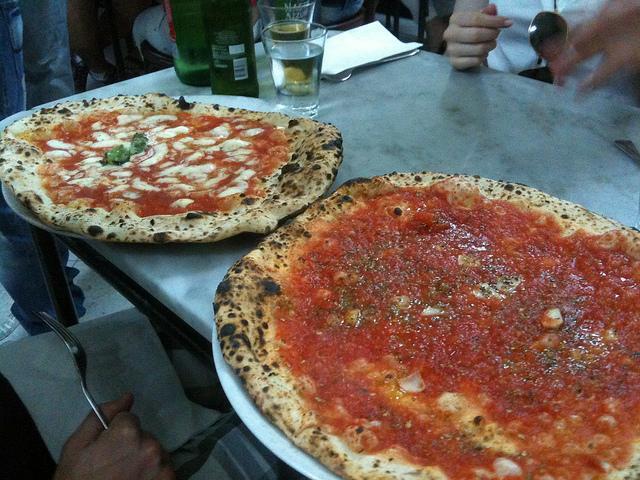How many pizzas are shown?
Give a very brief answer. 2. How many people are visible?
Give a very brief answer. 3. How many pizzas are visible?
Give a very brief answer. 2. How many bottles are there?
Give a very brief answer. 2. 